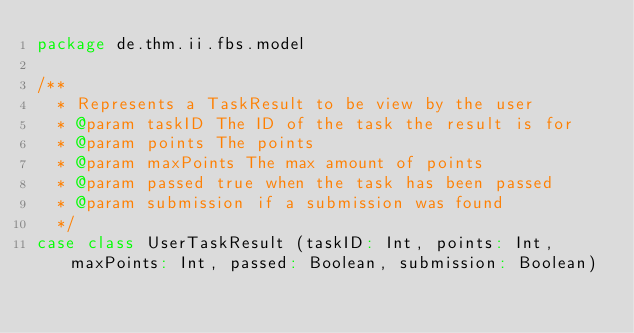Convert code to text. <code><loc_0><loc_0><loc_500><loc_500><_Scala_>package de.thm.ii.fbs.model

/**
  * Represents a TaskResult to be view by the user
  * @param taskID The ID of the task the result is for
  * @param points The points
  * @param maxPoints The max amount of points
  * @param passed true when the task has been passed
  * @param submission if a submission was found
  */
case class UserTaskResult (taskID: Int, points: Int, maxPoints: Int, passed: Boolean, submission: Boolean)
</code> 